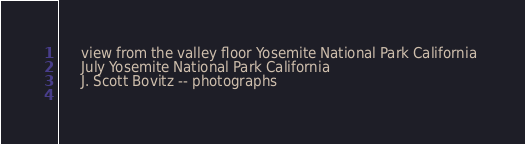<code> <loc_0><loc_0><loc_500><loc_500><_XML_>	 view from the valley floor Yosemite National Park California 
	 July Yosemite National Park California 
	 J. Scott Bovitz -- photographs 
	  
</code> 